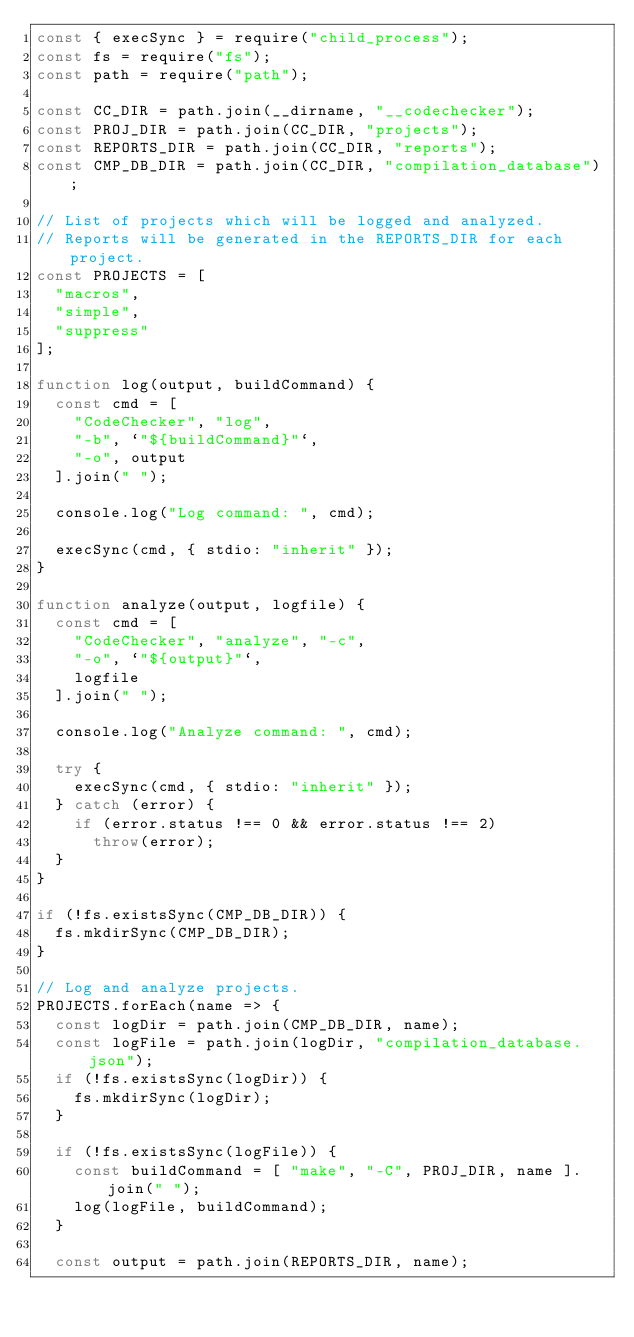Convert code to text. <code><loc_0><loc_0><loc_500><loc_500><_JavaScript_>const { execSync } = require("child_process");
const fs = require("fs");
const path = require("path");

const CC_DIR = path.join(__dirname, "__codechecker");
const PROJ_DIR = path.join(CC_DIR, "projects");
const REPORTS_DIR = path.join(CC_DIR, "reports");
const CMP_DB_DIR = path.join(CC_DIR, "compilation_database");

// List of projects which will be logged and analyzed.
// Reports will be generated in the REPORTS_DIR for each project.
const PROJECTS = [
  "macros",
  "simple",
  "suppress"
];

function log(output, buildCommand) {
  const cmd = [
    "CodeChecker", "log",
    "-b", `"${buildCommand}"`,
    "-o", output
  ].join(" ");

  console.log("Log command: ", cmd);

  execSync(cmd, { stdio: "inherit" });
}

function analyze(output, logfile) {
  const cmd = [
    "CodeChecker", "analyze", "-c",
    "-o", `"${output}"`,
    logfile
  ].join(" ");

  console.log("Analyze command: ", cmd);

  try {
    execSync(cmd, { stdio: "inherit" });
  } catch (error) {
    if (error.status !== 0 && error.status !== 2)
      throw(error);
  }
}

if (!fs.existsSync(CMP_DB_DIR)) {
  fs.mkdirSync(CMP_DB_DIR);
}

// Log and analyze projects.
PROJECTS.forEach(name => {
  const logDir = path.join(CMP_DB_DIR, name);
  const logFile = path.join(logDir, "compilation_database.json");
  if (!fs.existsSync(logDir)) {
    fs.mkdirSync(logDir);
  }

  if (!fs.existsSync(logFile)) {
    const buildCommand = [ "make", "-C", PROJ_DIR, name ].join(" ");
    log(logFile, buildCommand);
  }

  const output = path.join(REPORTS_DIR, name);</code> 